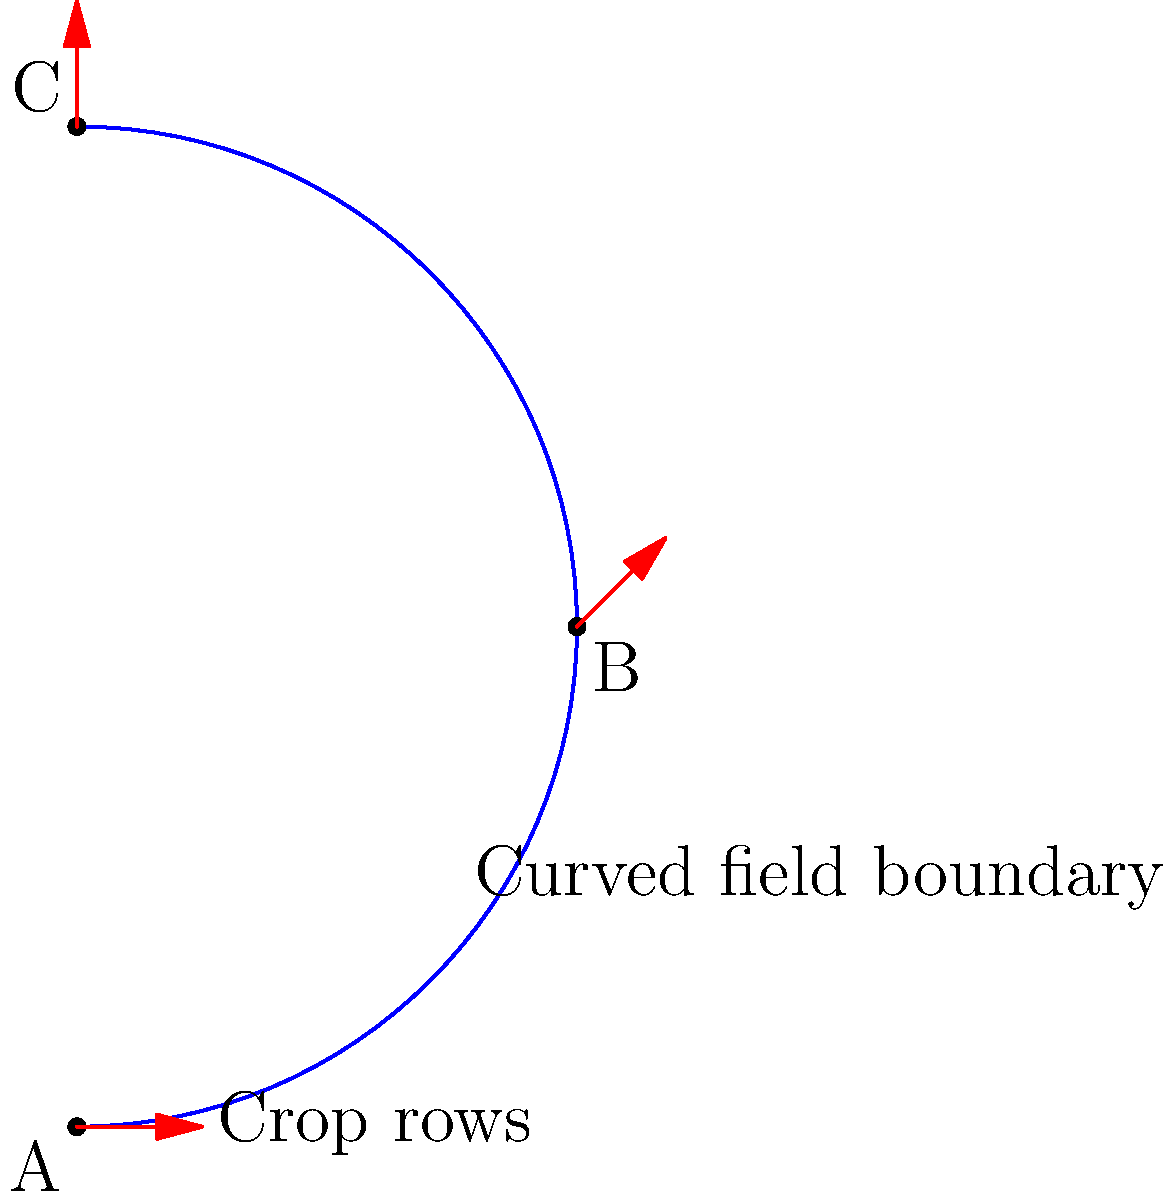A curved field boundary follows the path shown in blue. You want to plan crop rows that maintain a consistent angle relative to the field's curvature for efficient rotation. If the initial angle of the crop rows at point A is 0°, what will be the approximate angle of the crop rows at point C after parallel transport along the curve? To solve this problem, we need to understand the concept of parallel transport in non-Euclidean geometry and how it applies to the curved field boundary:

1. Parallel transport preserves the angle between a vector and the curve it's being transported along.

2. The curvature of the path causes the transported vector to rotate relative to a fixed coordinate system.

3. We can estimate the total rotation by breaking the curve into segments and summing the rotations:

   a) From A to B, the curve turns approximately 45° counterclockwise.
   b) From B to C, the curve turns another 45° counterclockwise.

4. The total rotation of the curve from A to C is about 90° counterclockwise.

5. Due to parallel transport, the crop row direction (represented by the red arrows) will rotate by the same amount as the curve's total rotation.

6. Therefore, the crop rows at point C will be rotated approximately 90° counterclockwise relative to their initial direction at point A.

7. Since the initial angle at A was 0°, the final angle at C will be about 90°.

This method ensures that the crop rows maintain a consistent relationship to the field's boundary, which can be beneficial for efficient use of space and resources in crop rotation planning.
Answer: Approximately 90° 